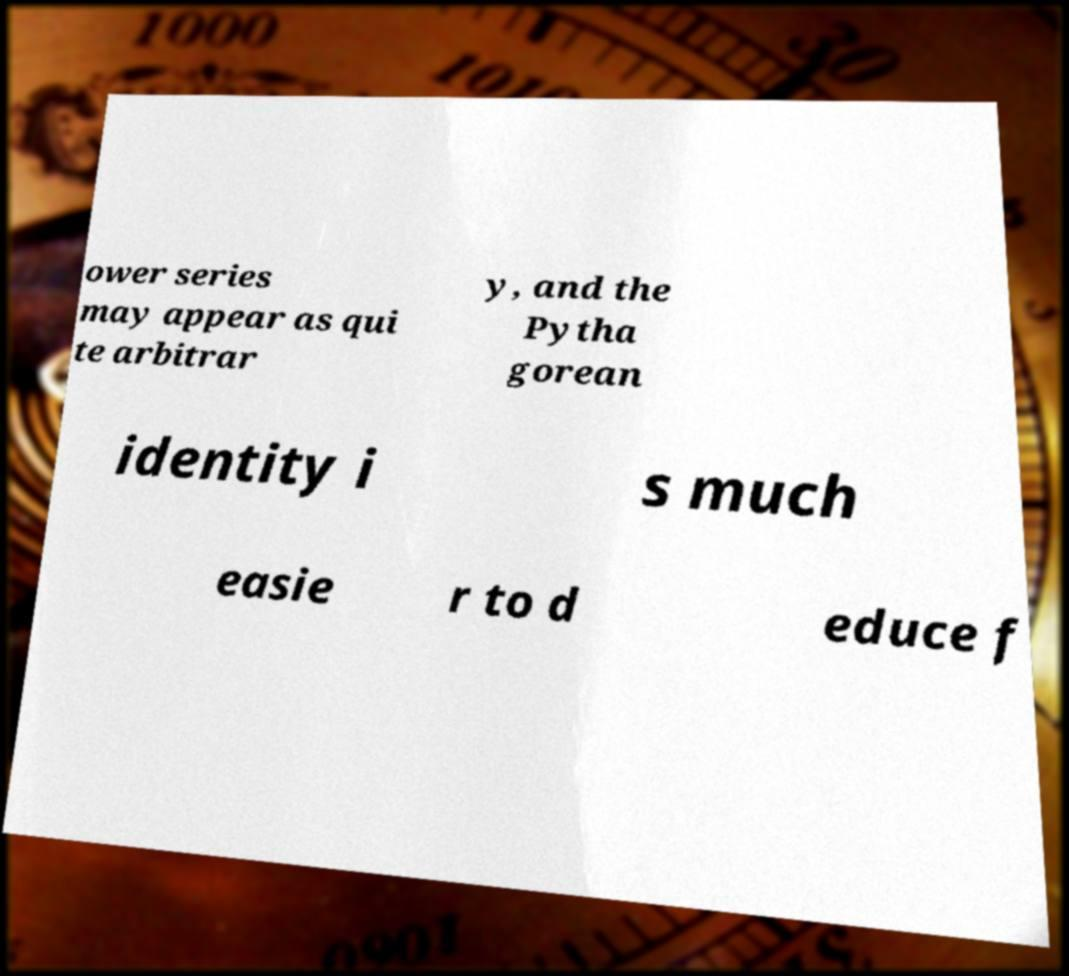What messages or text are displayed in this image? I need them in a readable, typed format. ower series may appear as qui te arbitrar y, and the Pytha gorean identity i s much easie r to d educe f 